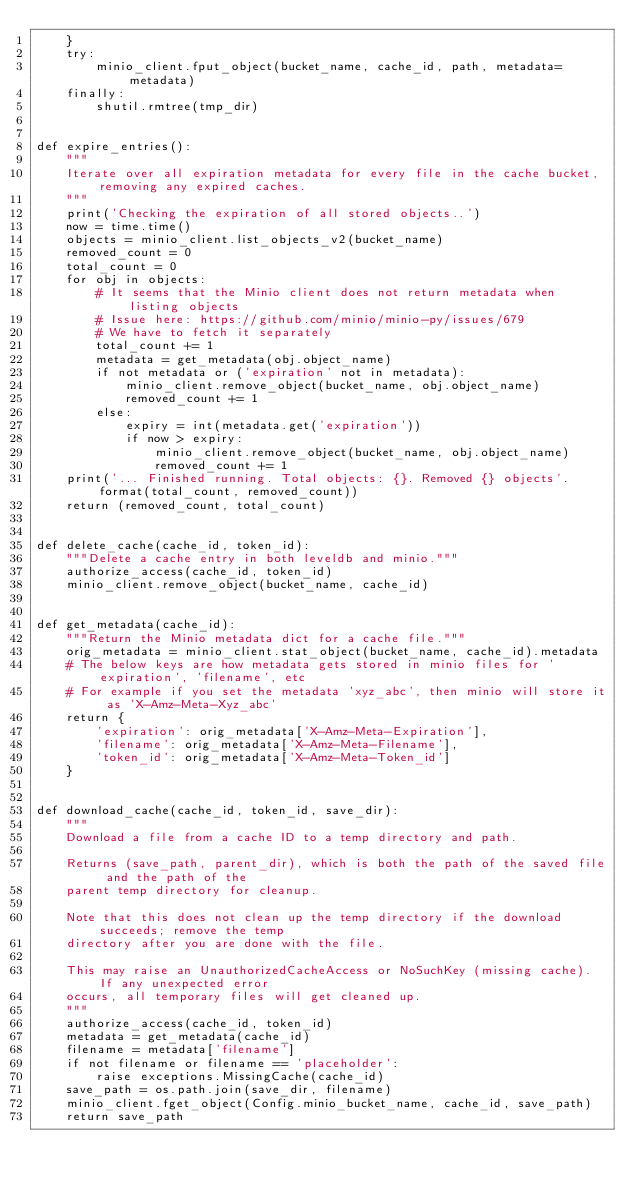<code> <loc_0><loc_0><loc_500><loc_500><_Python_>    }
    try:
        minio_client.fput_object(bucket_name, cache_id, path, metadata=metadata)
    finally:
        shutil.rmtree(tmp_dir)


def expire_entries():
    """
    Iterate over all expiration metadata for every file in the cache bucket, removing any expired caches.
    """
    print('Checking the expiration of all stored objects..')
    now = time.time()
    objects = minio_client.list_objects_v2(bucket_name)
    removed_count = 0
    total_count = 0
    for obj in objects:
        # It seems that the Minio client does not return metadata when listing objects
        # Issue here: https://github.com/minio/minio-py/issues/679
        # We have to fetch it separately
        total_count += 1
        metadata = get_metadata(obj.object_name)
        if not metadata or ('expiration' not in metadata):
            minio_client.remove_object(bucket_name, obj.object_name)
            removed_count += 1
        else:
            expiry = int(metadata.get('expiration'))
            if now > expiry:
                minio_client.remove_object(bucket_name, obj.object_name)
                removed_count += 1
    print('... Finished running. Total objects: {}. Removed {} objects'.format(total_count, removed_count))
    return (removed_count, total_count)


def delete_cache(cache_id, token_id):
    """Delete a cache entry in both leveldb and minio."""
    authorize_access(cache_id, token_id)
    minio_client.remove_object(bucket_name, cache_id)


def get_metadata(cache_id):
    """Return the Minio metadata dict for a cache file."""
    orig_metadata = minio_client.stat_object(bucket_name, cache_id).metadata
    # The below keys are how metadata gets stored in minio files for 'expiration', 'filename', etc
    # For example if you set the metadata 'xyz_abc', then minio will store it as 'X-Amz-Meta-Xyz_abc'
    return {
        'expiration': orig_metadata['X-Amz-Meta-Expiration'],
        'filename': orig_metadata['X-Amz-Meta-Filename'],
        'token_id': orig_metadata['X-Amz-Meta-Token_id']
    }


def download_cache(cache_id, token_id, save_dir):
    """
    Download a file from a cache ID to a temp directory and path.

    Returns (save_path, parent_dir), which is both the path of the saved file and the path of the
    parent temp directory for cleanup.

    Note that this does not clean up the temp directory if the download succeeds; remove the temp
    directory after you are done with the file.

    This may raise an UnauthorizedCacheAccess or NoSuchKey (missing cache). If any unexpected error
    occurs, all temporary files will get cleaned up.
    """
    authorize_access(cache_id, token_id)
    metadata = get_metadata(cache_id)
    filename = metadata['filename']
    if not filename or filename == 'placeholder':
        raise exceptions.MissingCache(cache_id)
    save_path = os.path.join(save_dir, filename)
    minio_client.fget_object(Config.minio_bucket_name, cache_id, save_path)
    return save_path
</code> 